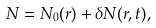<formula> <loc_0><loc_0><loc_500><loc_500>N = N _ { 0 } ( r ) + \delta N ( r , t ) ,</formula> 